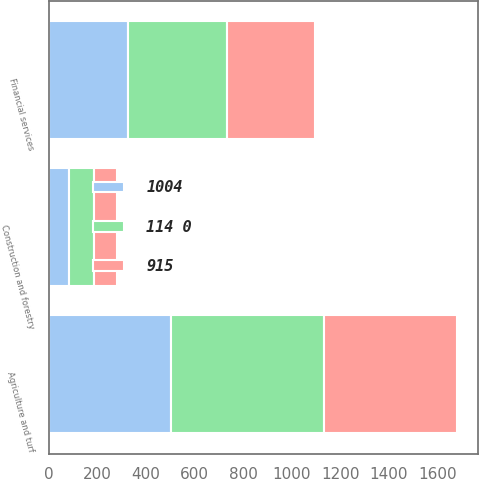<chart> <loc_0><loc_0><loc_500><loc_500><stacked_bar_chart><ecel><fcel>Agriculture and turf<fcel>Construction and forestry<fcel>Financial services<nl><fcel>114 0<fcel>627<fcel>106<fcel>407<nl><fcel>915<fcel>550<fcel>93<fcel>361<nl><fcel>1004<fcel>505<fcel>82<fcel>328<nl></chart> 